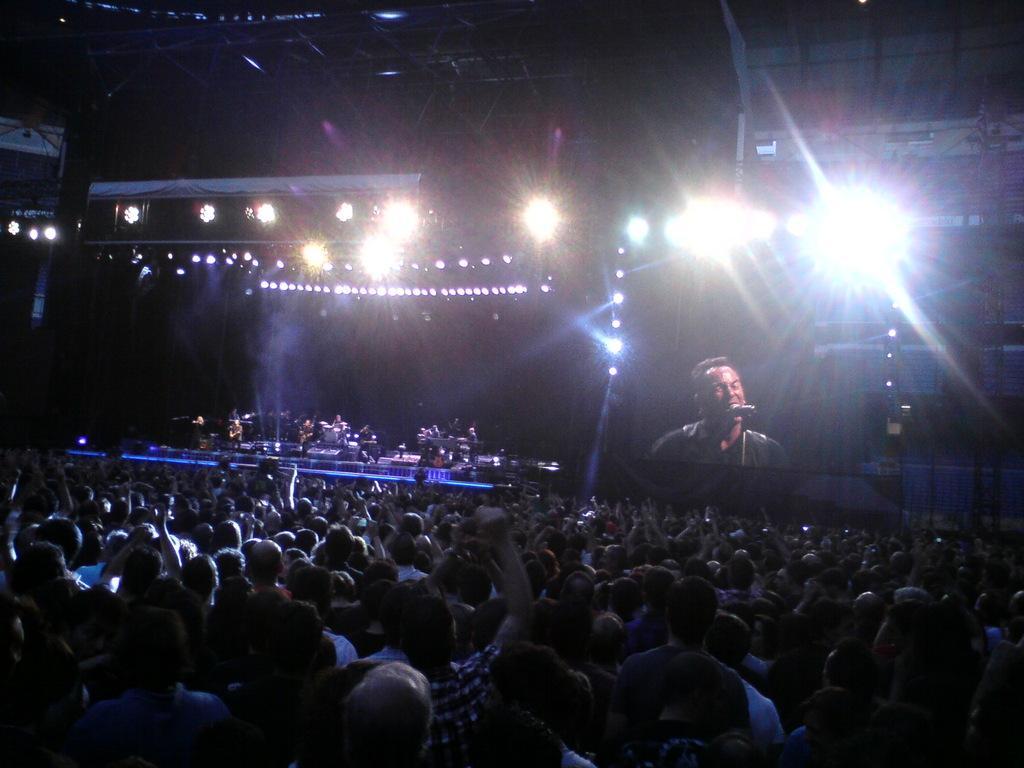Describe this image in one or two sentences. In the image we can see there are people standing on the ground and there is a stage on which people standing and holding musical instruments in their hand. Beside there is a screen on which a person is standing and in front of him there is a mic with a stand. 